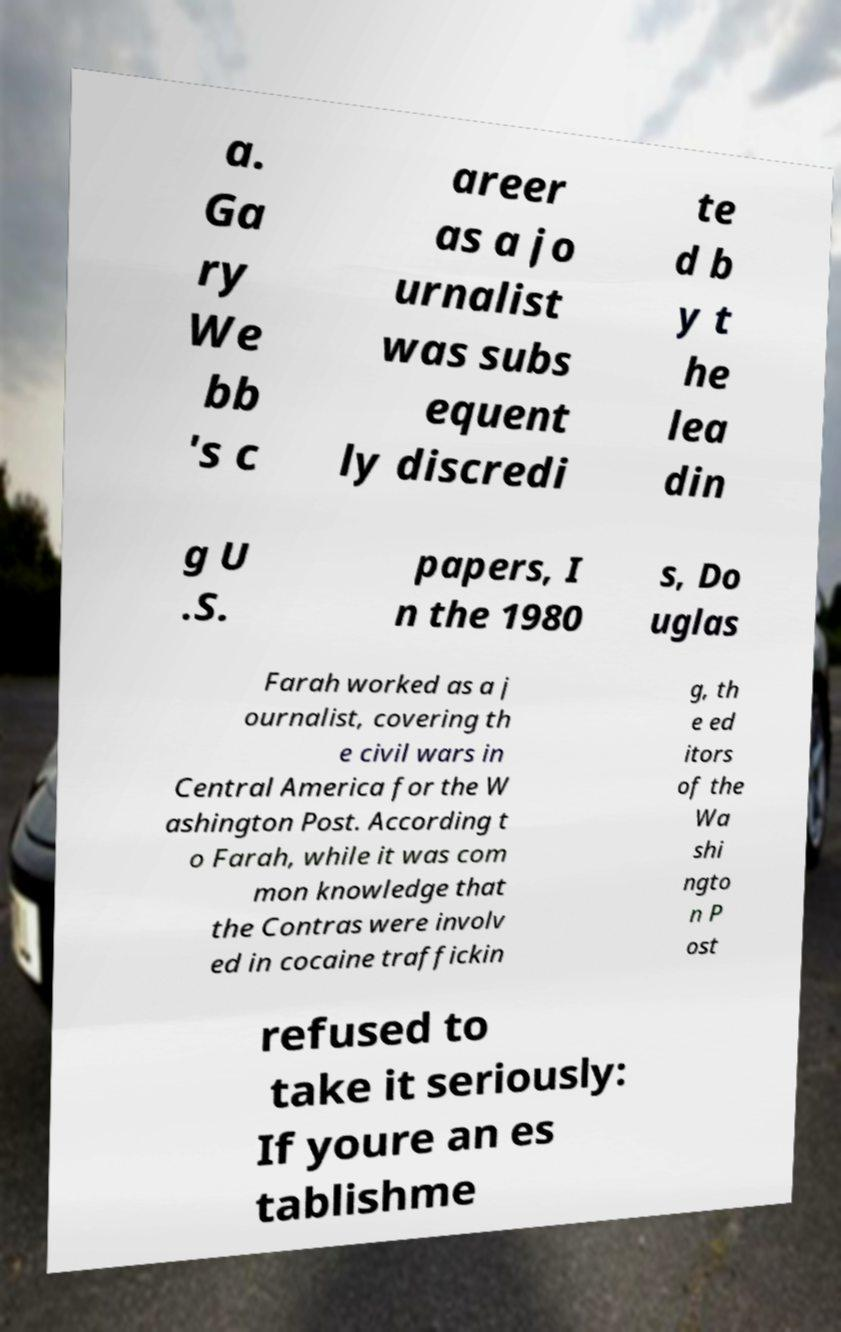Can you accurately transcribe the text from the provided image for me? a. Ga ry We bb 's c areer as a jo urnalist was subs equent ly discredi te d b y t he lea din g U .S. papers, I n the 1980 s, Do uglas Farah worked as a j ournalist, covering th e civil wars in Central America for the W ashington Post. According t o Farah, while it was com mon knowledge that the Contras were involv ed in cocaine traffickin g, th e ed itors of the Wa shi ngto n P ost refused to take it seriously: If youre an es tablishme 